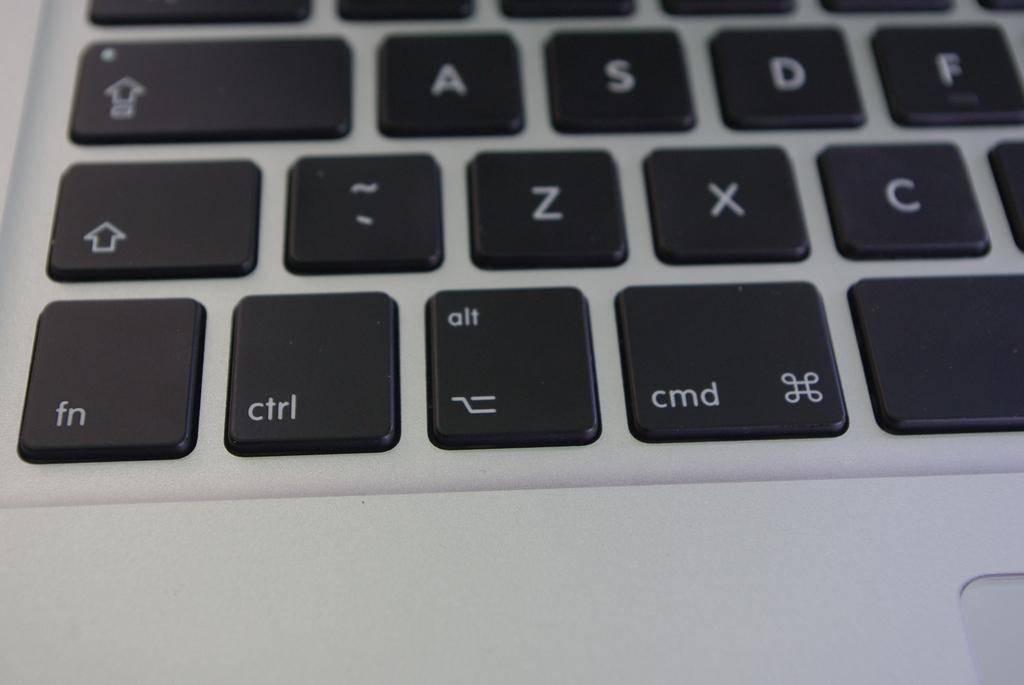<image>
Summarize the visual content of the image. The visible keys on a keyboard include ctrl, fn and cmd. 